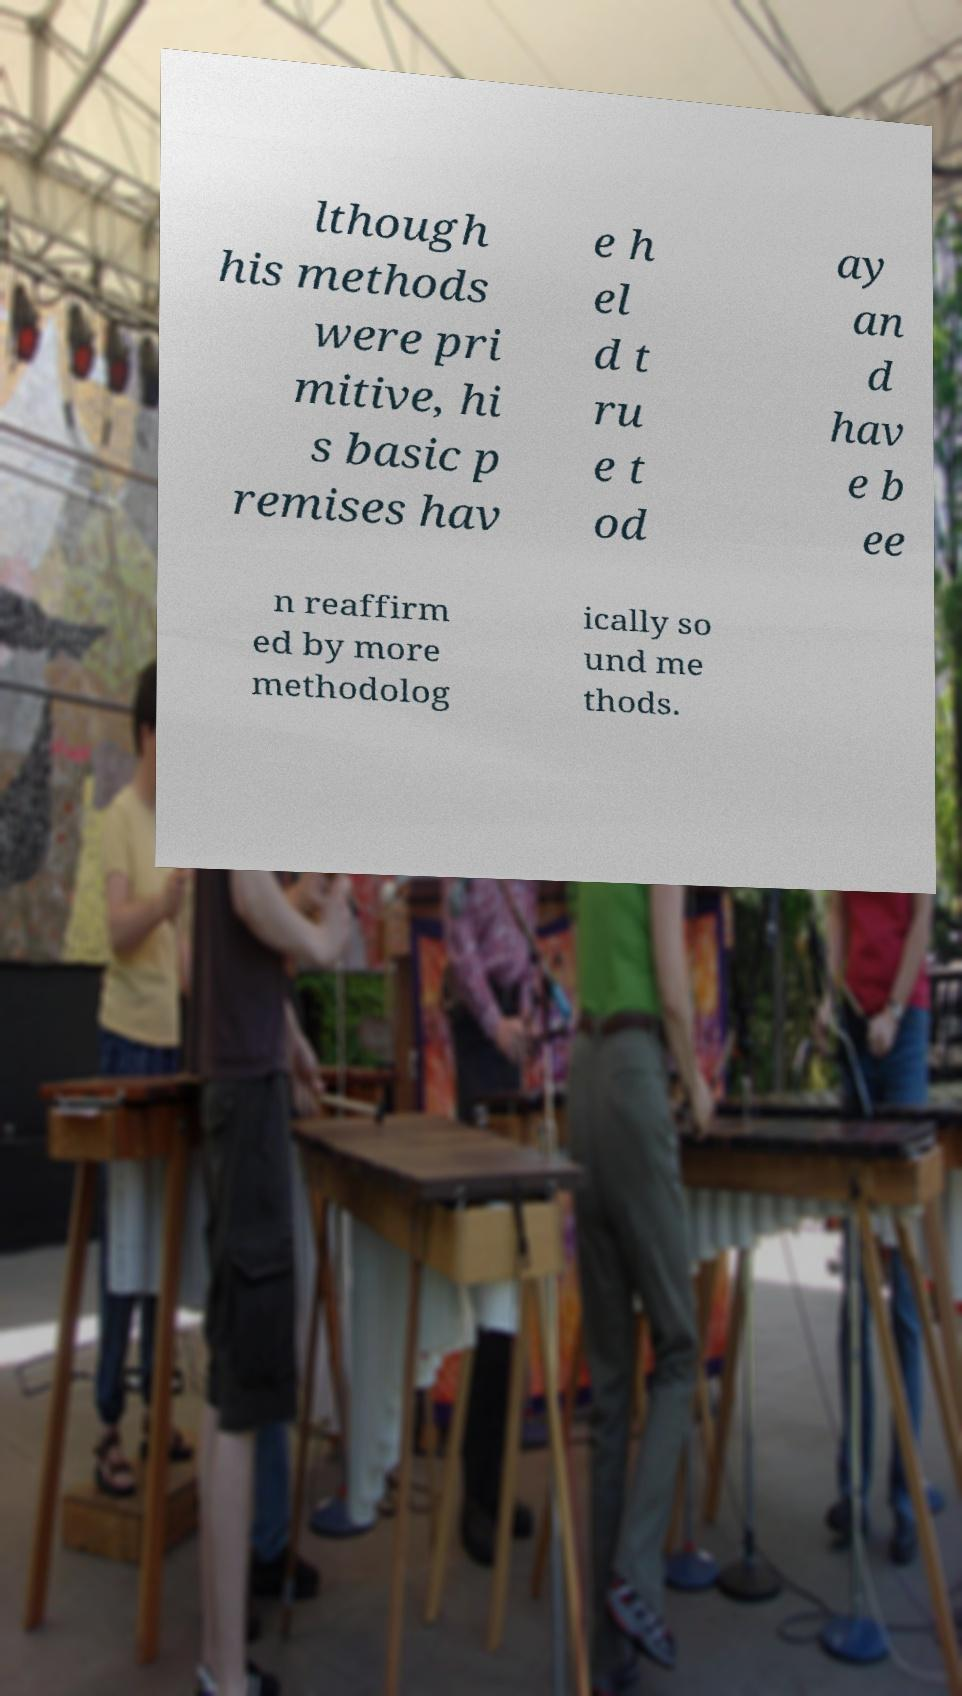Please identify and transcribe the text found in this image. lthough his methods were pri mitive, hi s basic p remises hav e h el d t ru e t od ay an d hav e b ee n reaffirm ed by more methodolog ically so und me thods. 